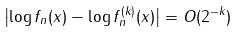Convert formula to latex. <formula><loc_0><loc_0><loc_500><loc_500>\left | \log f _ { n } ( x ) - \log f _ { n } ^ { ( k ) } ( x ) \right | = O ( 2 ^ { - k } )</formula> 